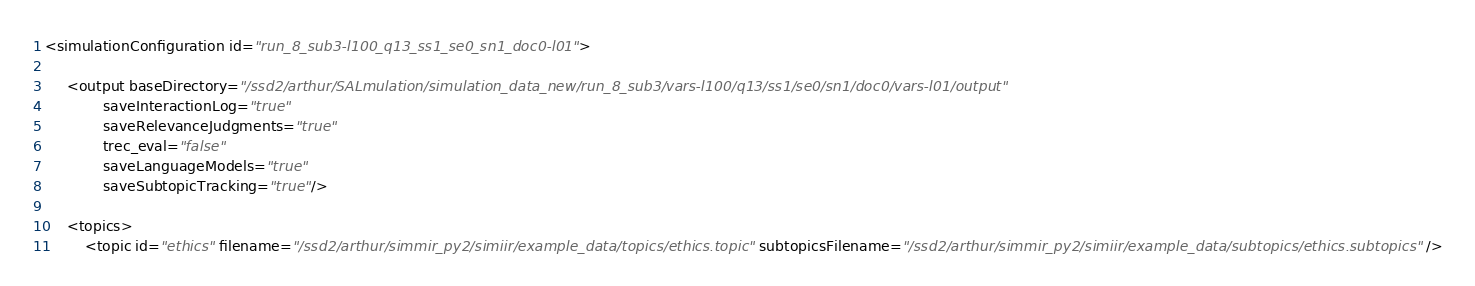<code> <loc_0><loc_0><loc_500><loc_500><_XML_><simulationConfiguration id="run_8_sub3-l100_q13_ss1_se0_sn1_doc0-l01">

     <output baseDirectory="/ssd2/arthur/SALmulation/simulation_data_new/run_8_sub3/vars-l100/q13/ss1/se0/sn1/doc0/vars-l01/output"
             saveInteractionLog="true"
             saveRelevanceJudgments="true"
             trec_eval="false"
             saveLanguageModels="true"
             saveSubtopicTracking="true"/>

     <topics>
         <topic id="ethics" filename="/ssd2/arthur/simmir_py2/simiir/example_data/topics/ethics.topic" subtopicsFilename="/ssd2/arthur/simmir_py2/simiir/example_data/subtopics/ethics.subtopics" /></code> 